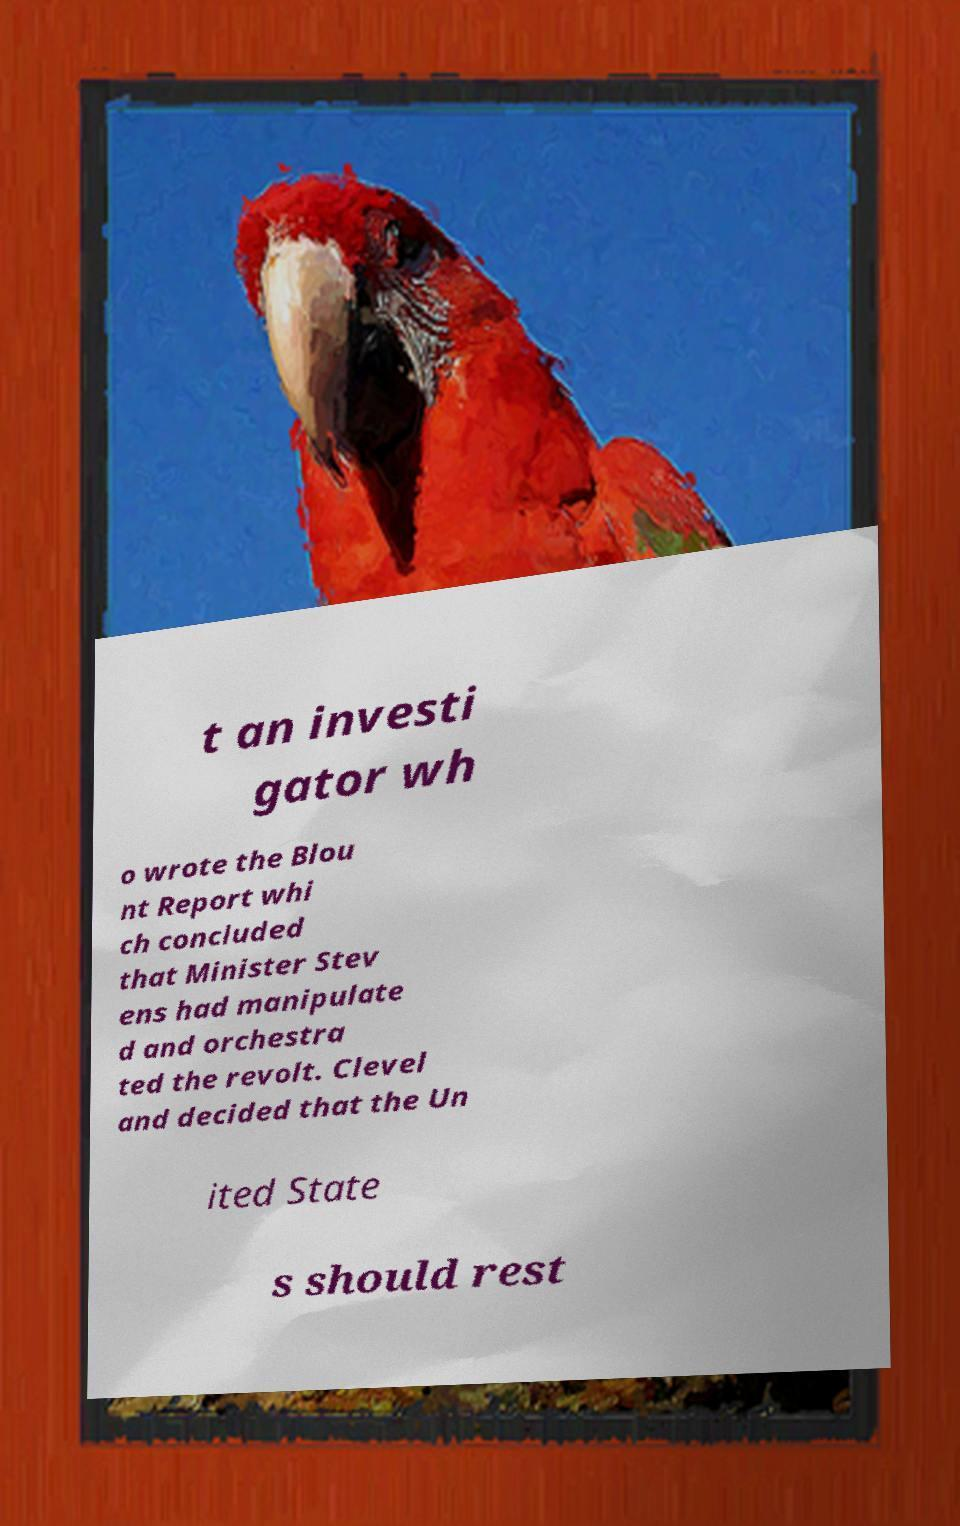Could you assist in decoding the text presented in this image and type it out clearly? t an investi gator wh o wrote the Blou nt Report whi ch concluded that Minister Stev ens had manipulate d and orchestra ted the revolt. Clevel and decided that the Un ited State s should rest 